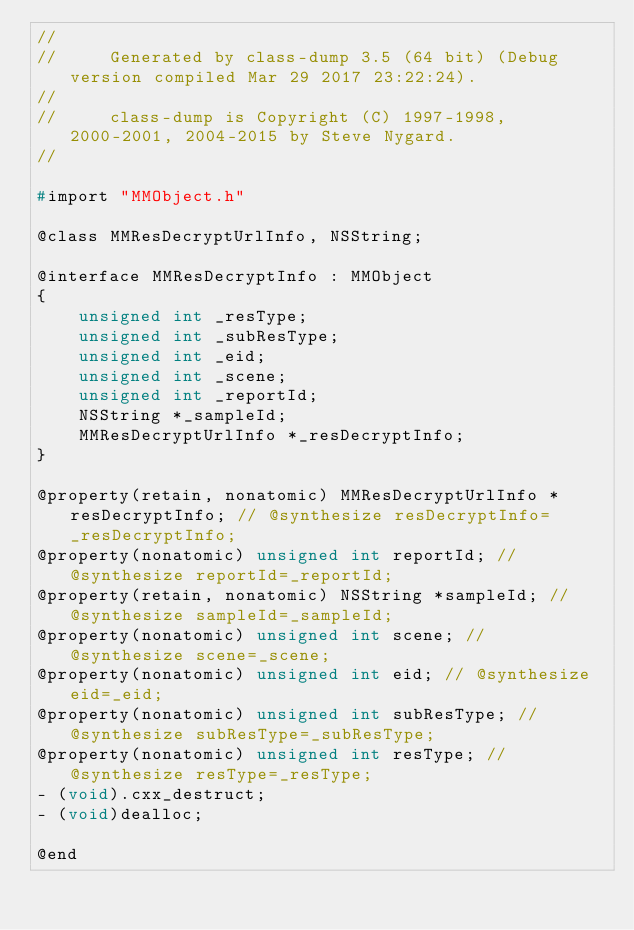<code> <loc_0><loc_0><loc_500><loc_500><_C_>//
//     Generated by class-dump 3.5 (64 bit) (Debug version compiled Mar 29 2017 23:22:24).
//
//     class-dump is Copyright (C) 1997-1998, 2000-2001, 2004-2015 by Steve Nygard.
//

#import "MMObject.h"

@class MMResDecryptUrlInfo, NSString;

@interface MMResDecryptInfo : MMObject
{
    unsigned int _resType;
    unsigned int _subResType;
    unsigned int _eid;
    unsigned int _scene;
    unsigned int _reportId;
    NSString *_sampleId;
    MMResDecryptUrlInfo *_resDecryptInfo;
}

@property(retain, nonatomic) MMResDecryptUrlInfo *resDecryptInfo; // @synthesize resDecryptInfo=_resDecryptInfo;
@property(nonatomic) unsigned int reportId; // @synthesize reportId=_reportId;
@property(retain, nonatomic) NSString *sampleId; // @synthesize sampleId=_sampleId;
@property(nonatomic) unsigned int scene; // @synthesize scene=_scene;
@property(nonatomic) unsigned int eid; // @synthesize eid=_eid;
@property(nonatomic) unsigned int subResType; // @synthesize subResType=_subResType;
@property(nonatomic) unsigned int resType; // @synthesize resType=_resType;
- (void).cxx_destruct;
- (void)dealloc;

@end

</code> 